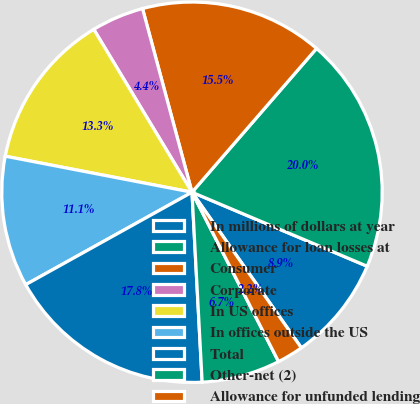<chart> <loc_0><loc_0><loc_500><loc_500><pie_chart><fcel>In millions of dollars at year<fcel>Allowance for loan losses at<fcel>Consumer<fcel>Corporate<fcel>In US offices<fcel>In offices outside the US<fcel>Total<fcel>Other-net (2)<fcel>Allowance for unfunded lending<nl><fcel>8.89%<fcel>20.0%<fcel>15.55%<fcel>4.45%<fcel>13.33%<fcel>11.11%<fcel>17.78%<fcel>6.67%<fcel>2.23%<nl></chart> 